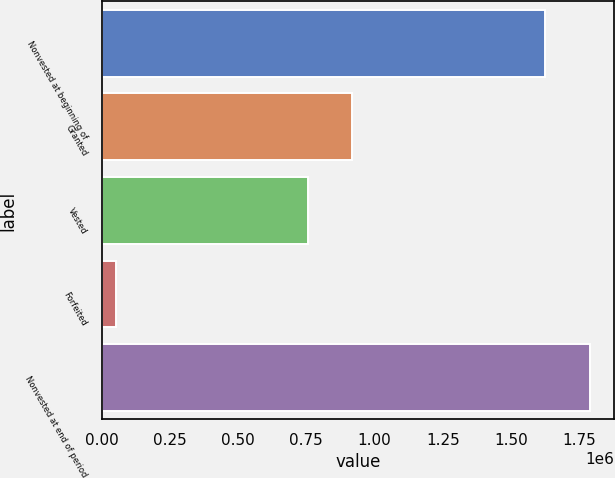Convert chart. <chart><loc_0><loc_0><loc_500><loc_500><bar_chart><fcel>Nonvested at beginning of<fcel>Granted<fcel>Vested<fcel>Forfeited<fcel>Nonvested at end of period<nl><fcel>1.62586e+06<fcel>918900<fcel>756310<fcel>53693<fcel>1.78845e+06<nl></chart> 